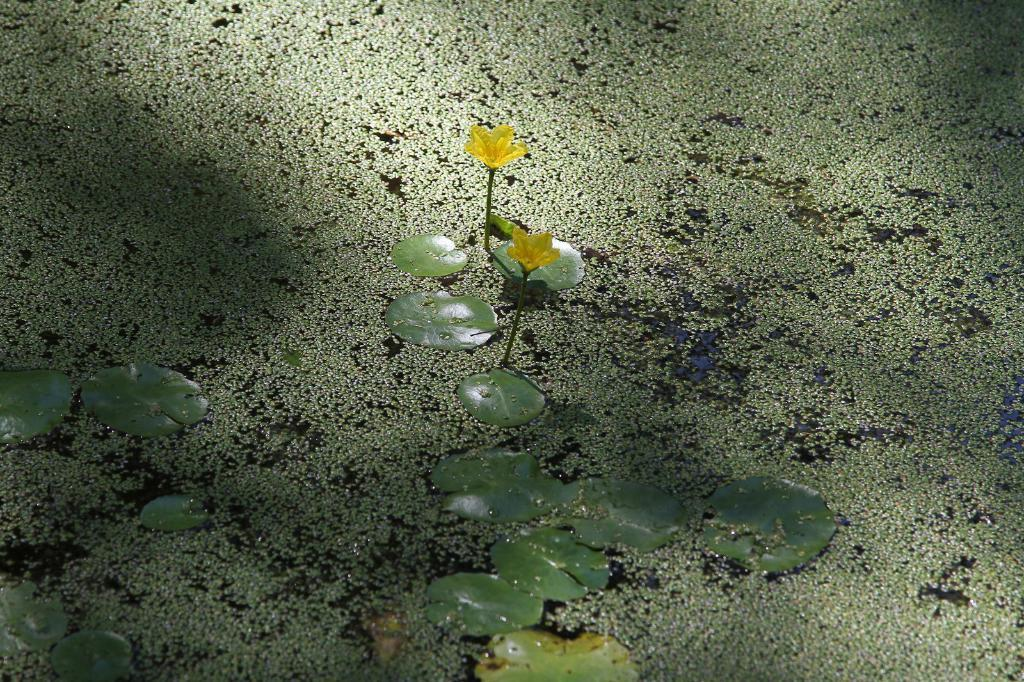What type of vegetation can be seen in the image? There are leaves in the image. What type of coal is being used to cut the holiday cake in the image? There is no coal or cake present in the image; it only features leaves. 